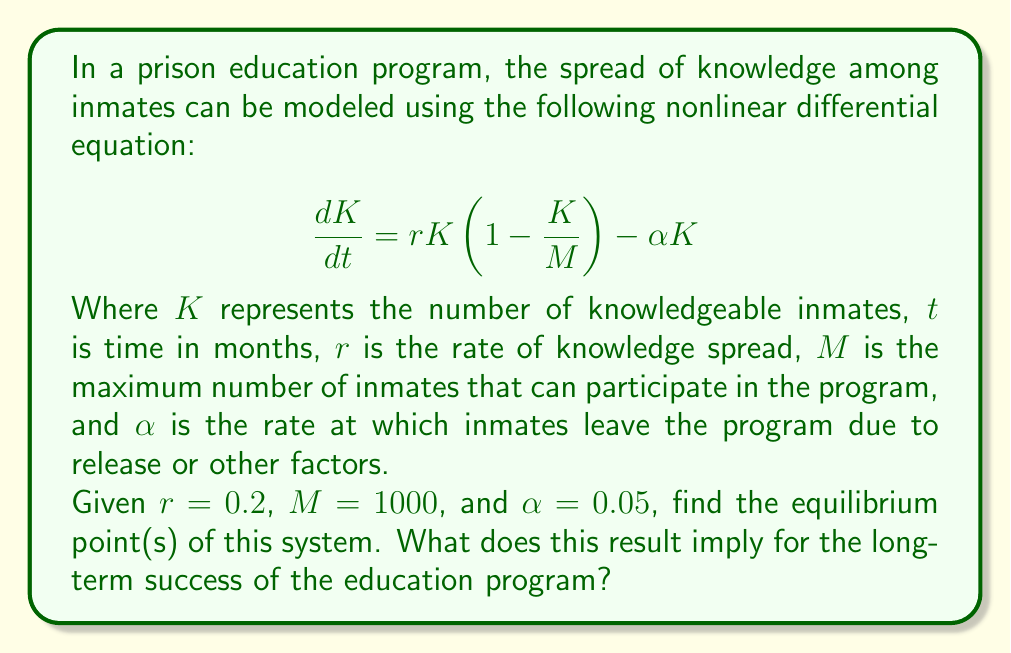Solve this math problem. To find the equilibrium points, we set $\frac{dK}{dt} = 0$ and solve for $K$:

$$0 = rK(1-\frac{K}{M}) - \alpha K$$

$$0 = 0.2K(1-\frac{K}{1000}) - 0.05K$$

Factoring out $K$:

$$0 = K(0.2(1-\frac{K}{1000}) - 0.05)$$

This equation is satisfied when either $K = 0$ or the term in parentheses equals zero. Let's solve the second case:

$$0.2(1-\frac{K}{1000}) - 0.05 = 0$$

$$0.2 - \frac{0.2K}{1000} - 0.05 = 0$$

$$0.15 - \frac{0.2K}{1000} = 0$$

$$0.15 = \frac{0.2K}{1000}$$

$$750 = K$$

Therefore, the equilibrium points are $K = 0$ and $K = 750$.

The non-zero equilibrium point ($K = 750$) represents a stable state where the number of knowledgeable inmates remains constant. This implies that in the long term, the education program can successfully maintain a significant portion (75%) of the maximum capacity engaged in learning, despite the continuous influx and outflow of inmates.

The zero equilibrium point ($K = 0$) is unstable and represents a state where the program has failed to engage any inmates, which is unlikely in practice given a well-designed education initiative.
Answer: Equilibrium points: $K = 0$ and $K = 750$ 